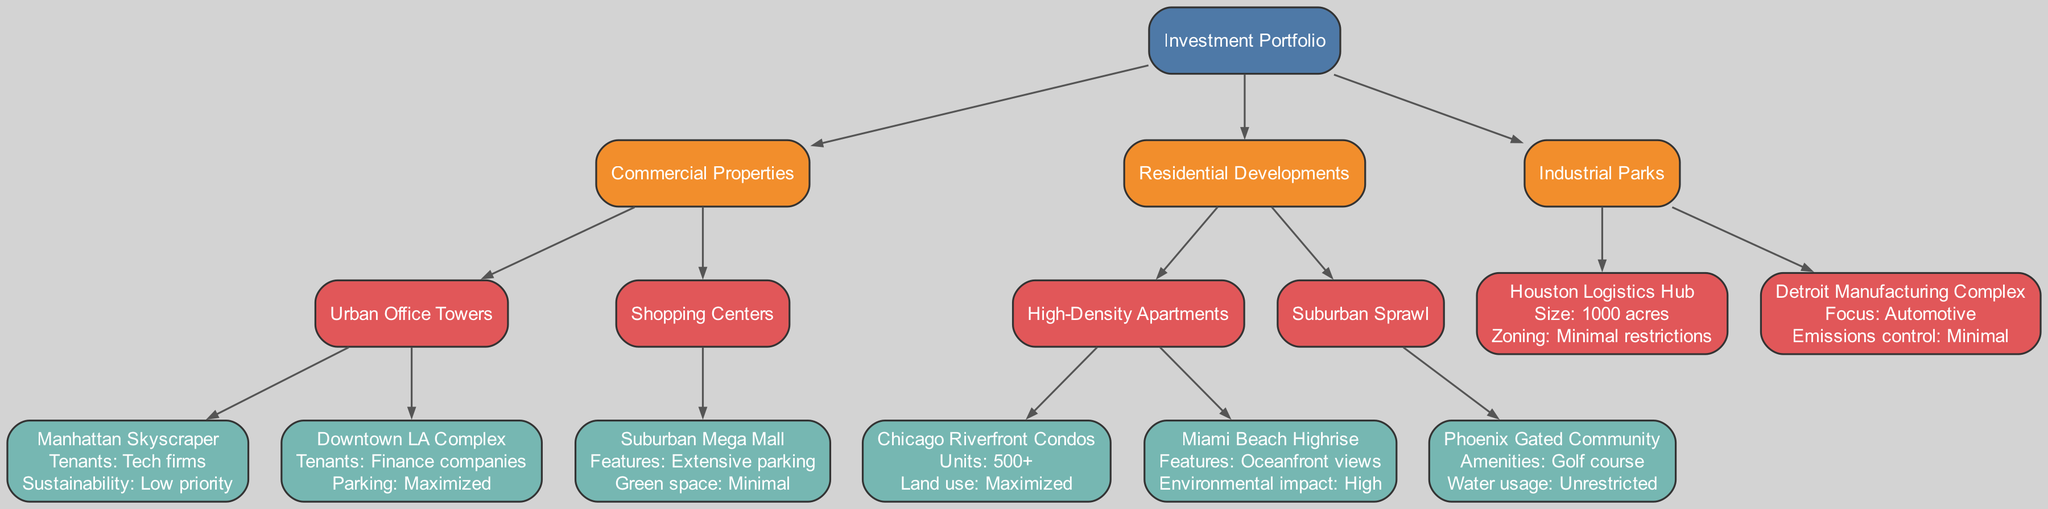What type of properties does the investment portfolio include? The investment portfolio includes three major categories: Commercial Properties, Residential Developments, and Industrial Parks. These reflect the diverse areas of investment within the real estate sector.
Answer: Commercial Properties, Residential Developments, Industrial Parks How many tenants are in the Manhattan Skyscraper? The Manhattan Skyscraper lists "Tech firms" as its tenants. This detail indicates the type of businesses operating within that property, rather than a specific numeric value.
Answer: Tech firms What is the main focus of the Detroit Manufacturing Complex? The focus of the Detroit Manufacturing Complex is on "Automotive." This defines the primary industry and market that the complex is catering to within the industrial sector.
Answer: Automotive Which residential development has oceanfront views? The Miami Beach Highrise is characterized by its "Oceanfront views," highlighting its location and appeal as a luxury residential property.
Answer: Oceanfront views What is the zoning status of the Houston Logistics Hub? The zoning of the Houston Logistics Hub has "Minimal restrictions." This implies that development and use of the property can be more flexible without stringent regulatory oversight.
Answer: Minimal restrictions What are the amenities of the Phoenix Gated Community? The Phoenix Gated Community is noted for having a "Golf course" as an amenity, which adds value and attractiveness to the residential area.
Answer: Golf course How many units are there in the Chicago Riverfront Condos? The Chicago Riverfront Condos has "500+" units, indicating that it is a large-scale residential development designed to accommodate many residents.
Answer: 500+ What type of parking strategy does the Downtown LA Complex employ? The Downtown LA Complex uses a "Maximized" parking strategy, which indicates a focus on providing ample parking space to accommodate its tenants.
Answer: Maximized How is the environmental impact characterized for the Miami Beach Highrise? The environmental impact of the Miami Beach Highrise is noted as "High," indicating that the property may have significant ecological or environmentally detrimental effects.
Answer: High 